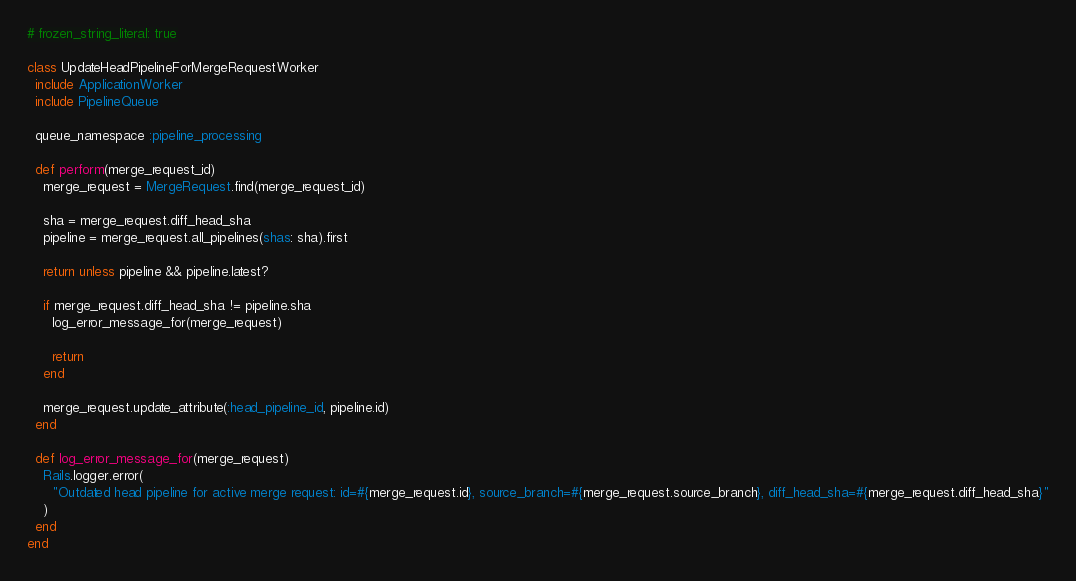Convert code to text. <code><loc_0><loc_0><loc_500><loc_500><_Ruby_># frozen_string_literal: true

class UpdateHeadPipelineForMergeRequestWorker
  include ApplicationWorker
  include PipelineQueue

  queue_namespace :pipeline_processing

  def perform(merge_request_id)
    merge_request = MergeRequest.find(merge_request_id)

    sha = merge_request.diff_head_sha
    pipeline = merge_request.all_pipelines(shas: sha).first

    return unless pipeline && pipeline.latest?

    if merge_request.diff_head_sha != pipeline.sha
      log_error_message_for(merge_request)

      return
    end

    merge_request.update_attribute(:head_pipeline_id, pipeline.id)
  end

  def log_error_message_for(merge_request)
    Rails.logger.error(
      "Outdated head pipeline for active merge request: id=#{merge_request.id}, source_branch=#{merge_request.source_branch}, diff_head_sha=#{merge_request.diff_head_sha}"
    )
  end
end
</code> 